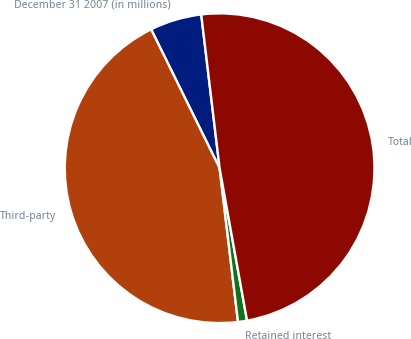Convert chart. <chart><loc_0><loc_0><loc_500><loc_500><pie_chart><fcel>December 31 2007 (in millions)<fcel>Third-party<fcel>Retained interest<fcel>Total<nl><fcel>5.4%<fcel>44.6%<fcel>0.94%<fcel>49.06%<nl></chart> 